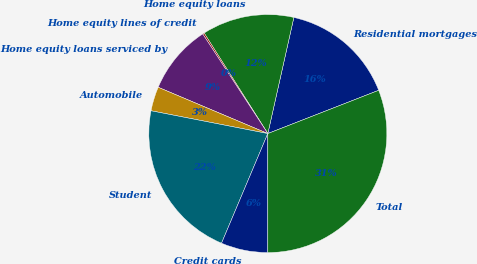<chart> <loc_0><loc_0><loc_500><loc_500><pie_chart><fcel>Residential mortgages<fcel>Home equity loans<fcel>Home equity lines of credit<fcel>Home equity loans serviced by<fcel>Automobile<fcel>Student<fcel>Credit cards<fcel>Total<nl><fcel>15.57%<fcel>12.5%<fcel>0.22%<fcel>9.43%<fcel>3.29%<fcel>21.71%<fcel>6.36%<fcel>30.92%<nl></chart> 